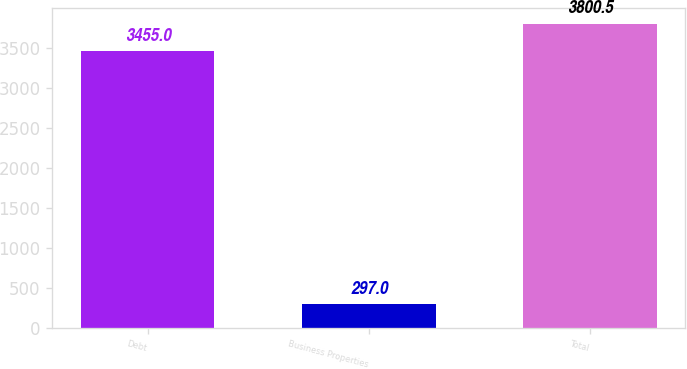Convert chart to OTSL. <chart><loc_0><loc_0><loc_500><loc_500><bar_chart><fcel>Debt<fcel>Business Properties<fcel>Total<nl><fcel>3455<fcel>297<fcel>3800.5<nl></chart> 